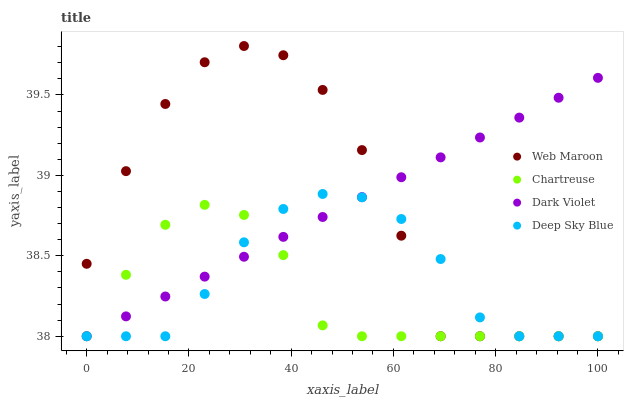Does Chartreuse have the minimum area under the curve?
Answer yes or no. Yes. Does Web Maroon have the maximum area under the curve?
Answer yes or no. Yes. Does Deep Sky Blue have the minimum area under the curve?
Answer yes or no. No. Does Deep Sky Blue have the maximum area under the curve?
Answer yes or no. No. Is Dark Violet the smoothest?
Answer yes or no. Yes. Is Web Maroon the roughest?
Answer yes or no. Yes. Is Deep Sky Blue the smoothest?
Answer yes or no. No. Is Deep Sky Blue the roughest?
Answer yes or no. No. Does Chartreuse have the lowest value?
Answer yes or no. Yes. Does Web Maroon have the highest value?
Answer yes or no. Yes. Does Deep Sky Blue have the highest value?
Answer yes or no. No. Does Deep Sky Blue intersect Web Maroon?
Answer yes or no. Yes. Is Deep Sky Blue less than Web Maroon?
Answer yes or no. No. Is Deep Sky Blue greater than Web Maroon?
Answer yes or no. No. 